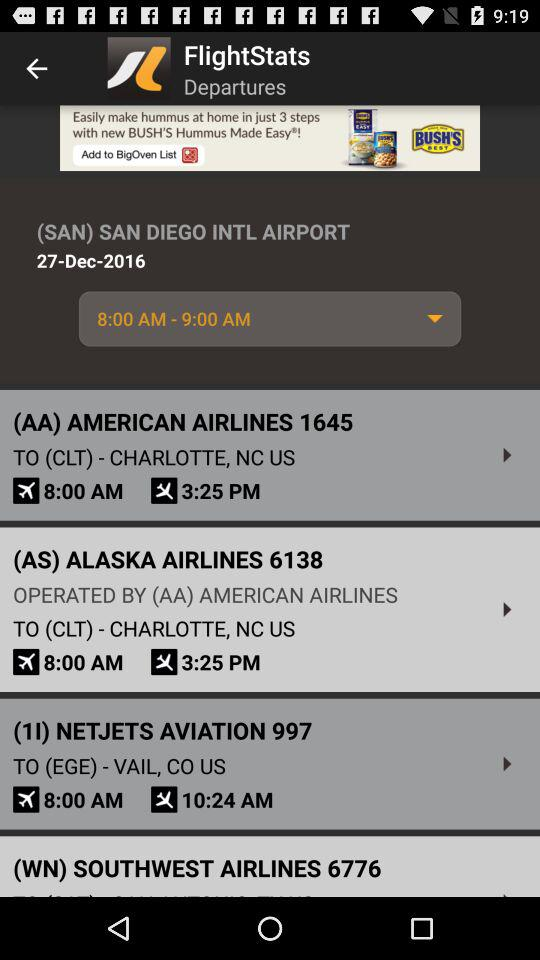What is the flight arrival time in Charlotte? The flight arrival time in Charlotte is 3:25 PM. 